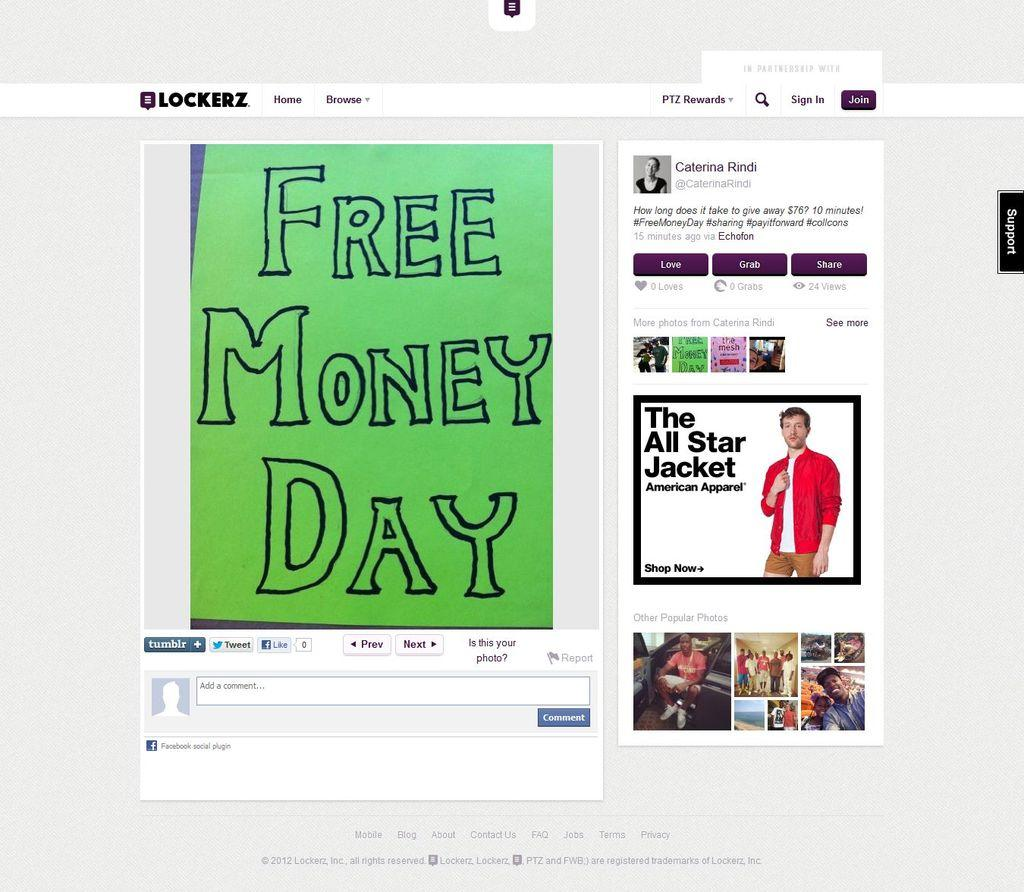<image>
Share a concise interpretation of the image provided. The website Lockerz has a green Free Money Day sign posted on it. 